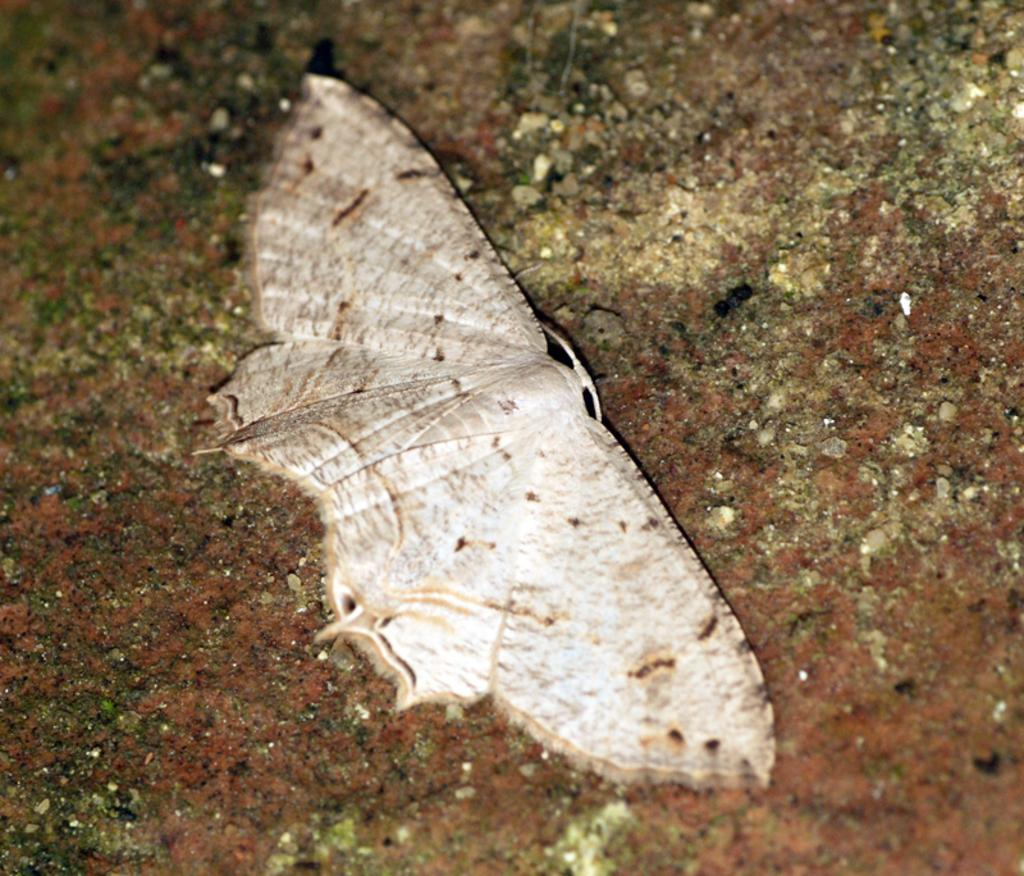What type of creature is present in the image? There is an insect in the image. What is the color of the surface where the insect is located? The insect is on a red surface. Where is the boy carrying the sack in the image? There is no boy carrying a sack present in the image; it only features an insect on a red surface. What type of plant is growing near the insect in the image? There is no plant present in the image; it only features an insect on a red surface. 